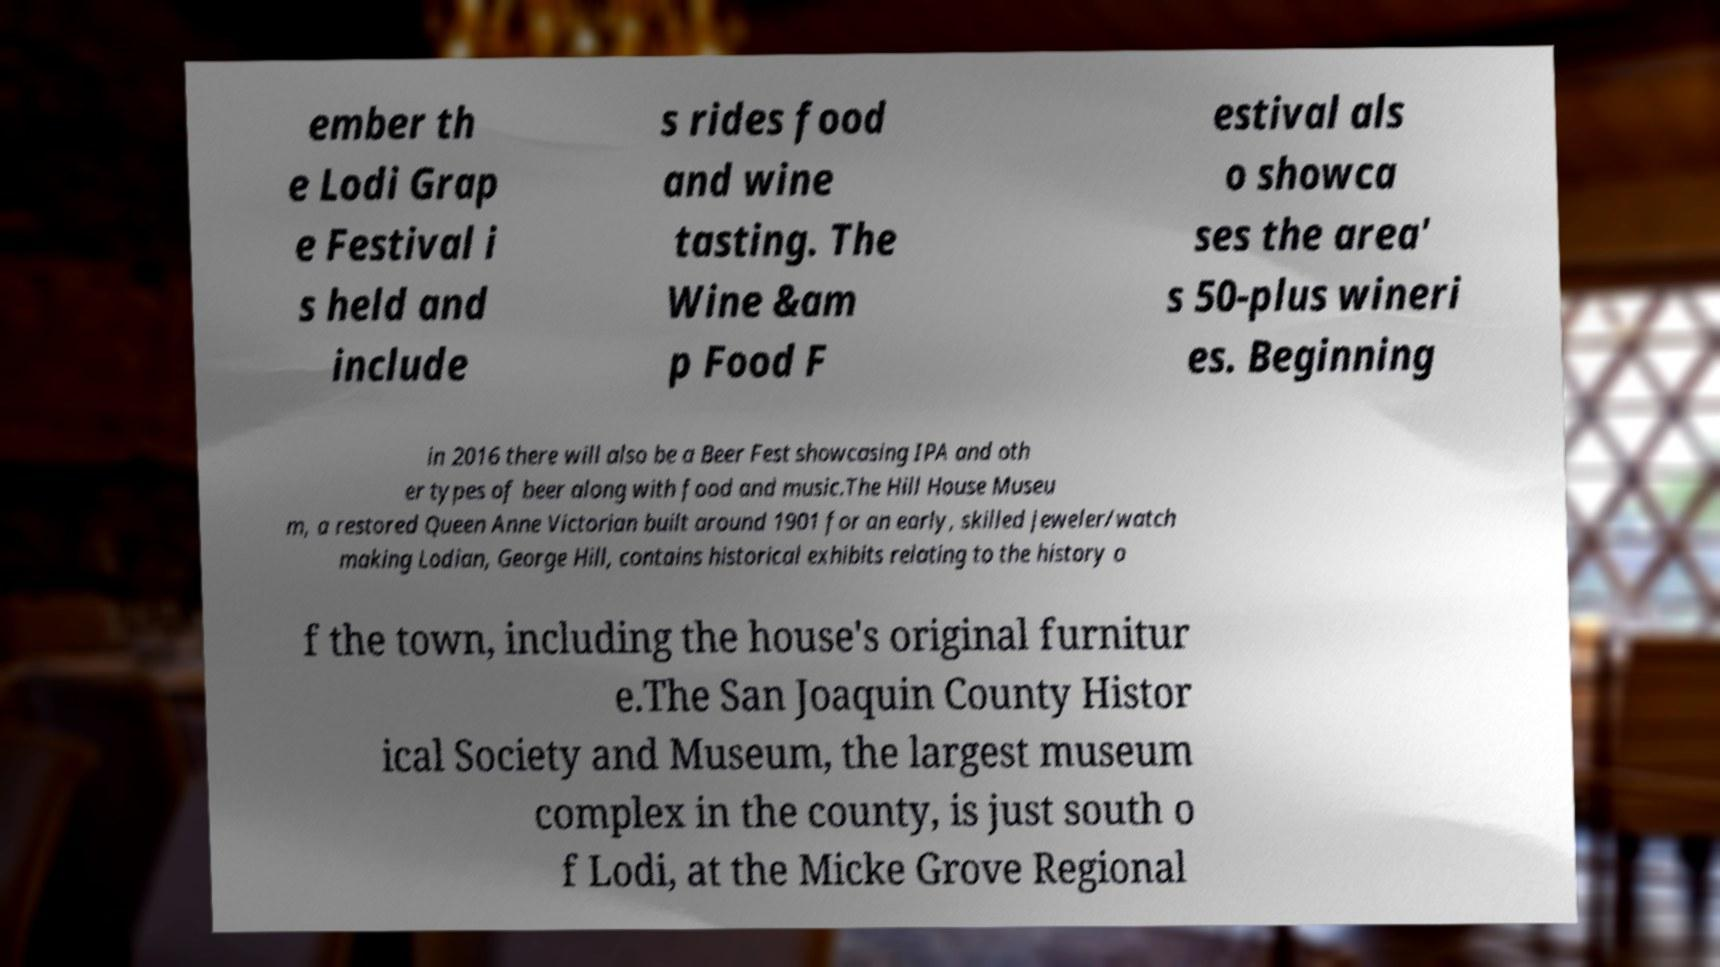Can you read and provide the text displayed in the image?This photo seems to have some interesting text. Can you extract and type it out for me? ember th e Lodi Grap e Festival i s held and include s rides food and wine tasting. The Wine &am p Food F estival als o showca ses the area' s 50-plus wineri es. Beginning in 2016 there will also be a Beer Fest showcasing IPA and oth er types of beer along with food and music.The Hill House Museu m, a restored Queen Anne Victorian built around 1901 for an early, skilled jeweler/watch making Lodian, George Hill, contains historical exhibits relating to the history o f the town, including the house's original furnitur e.The San Joaquin County Histor ical Society and Museum, the largest museum complex in the county, is just south o f Lodi, at the Micke Grove Regional 